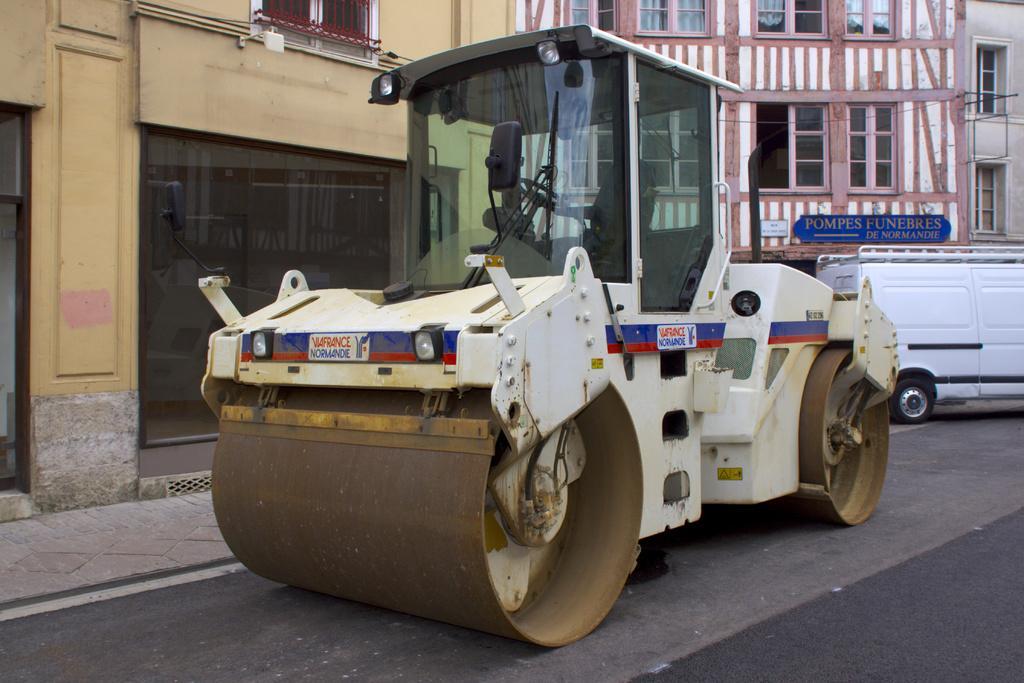Can you describe this image briefly? In this picture we can see a road roller and a vehicle on the road. Behind the vehicles there are buildings with windows, glass doors and a name board. 